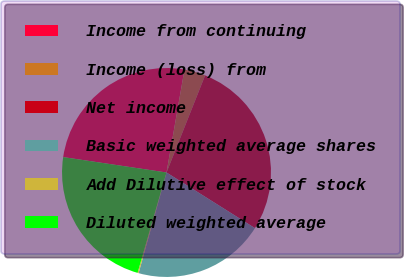Convert chart to OTSL. <chart><loc_0><loc_0><loc_500><loc_500><pie_chart><fcel>Income from continuing<fcel>Income (loss) from<fcel>Net income<fcel>Basic weighted average shares<fcel>Add Dilutive effect of stock<fcel>Diluted weighted average<nl><fcel>25.4%<fcel>3.27%<fcel>27.92%<fcel>20.37%<fcel>0.16%<fcel>22.89%<nl></chart> 